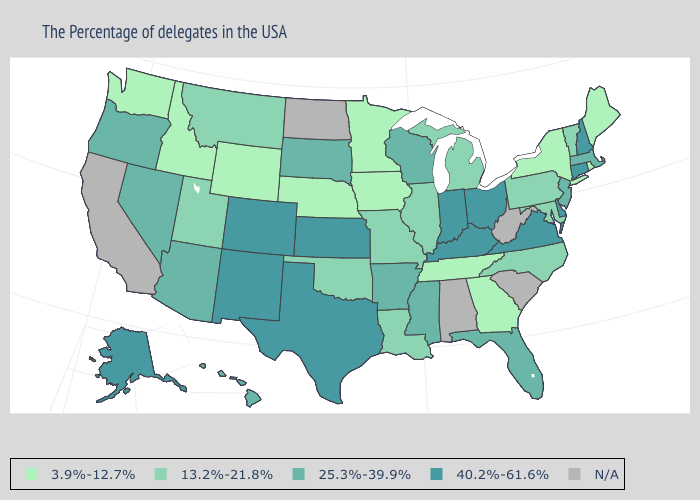What is the value of Indiana?
Answer briefly. 40.2%-61.6%. Name the states that have a value in the range N/A?
Be succinct. South Carolina, West Virginia, Alabama, North Dakota, California. Name the states that have a value in the range 25.3%-39.9%?
Write a very short answer. Massachusetts, New Jersey, Florida, Wisconsin, Mississippi, Arkansas, South Dakota, Arizona, Nevada, Oregon, Hawaii. What is the highest value in the USA?
Keep it brief. 40.2%-61.6%. Name the states that have a value in the range 40.2%-61.6%?
Keep it brief. New Hampshire, Connecticut, Delaware, Virginia, Ohio, Kentucky, Indiana, Kansas, Texas, Colorado, New Mexico, Alaska. Name the states that have a value in the range 40.2%-61.6%?
Give a very brief answer. New Hampshire, Connecticut, Delaware, Virginia, Ohio, Kentucky, Indiana, Kansas, Texas, Colorado, New Mexico, Alaska. Does Georgia have the highest value in the South?
Quick response, please. No. Which states have the lowest value in the USA?
Keep it brief. Maine, Rhode Island, New York, Georgia, Tennessee, Minnesota, Iowa, Nebraska, Wyoming, Idaho, Washington. Does Florida have the highest value in the USA?
Give a very brief answer. No. Which states have the highest value in the USA?
Concise answer only. New Hampshire, Connecticut, Delaware, Virginia, Ohio, Kentucky, Indiana, Kansas, Texas, Colorado, New Mexico, Alaska. What is the highest value in states that border New Hampshire?
Quick response, please. 25.3%-39.9%. Name the states that have a value in the range N/A?
Be succinct. South Carolina, West Virginia, Alabama, North Dakota, California. What is the highest value in the USA?
Be succinct. 40.2%-61.6%. What is the highest value in the USA?
Be succinct. 40.2%-61.6%. What is the value of Arizona?
Write a very short answer. 25.3%-39.9%. 